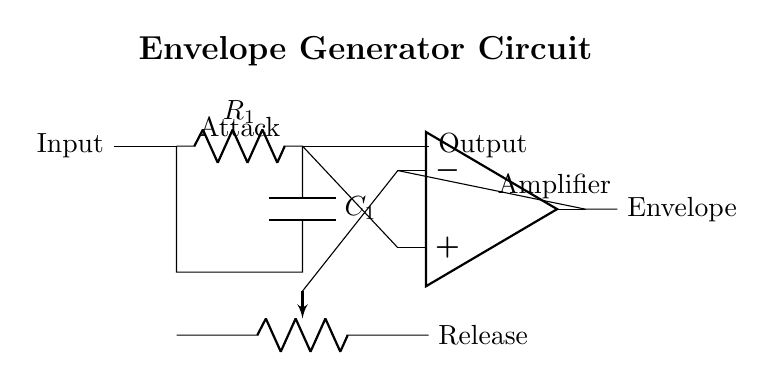what is the first component in the circuit? The first component is a resistor labeled R1, which is connected to the input of the circuit.
Answer: resistor R1 what type of capacitor is used in this circuit? The circuit uses a capacitor labeled C1, indicating a standard capacitor.
Answer: capacitor C1 what connects the capacitor to the output? The output is connected through the op-amp, which receives the voltage from the capacitor.
Answer: op-amp what is the role of the potentiometer in this circuit? The potentiometer allows for adjusting the resistance, which affects the attack and release characteristics of the envelope generator.
Answer: adjustable resistance how does the op-amp influence the envelope signal? The op-amp amplifies the voltage signal coming from the RC circuit, producing an output envelope that shapes the sound.
Answer: amplifies the signal what affects the attack time in the envelope generator? The attack time is primarily affected by the values of R1 (resistor) and C1 (capacitor) in the RC time constant formula.
Answer: resistor and capacitor values which part of the circuit controls the release time? The release time is controlled by the potentiometer, which adjusts the resistance in the circuit.
Answer: potentiometer 